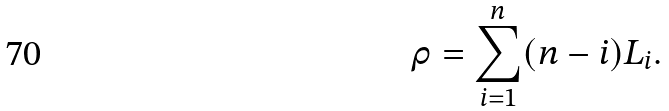Convert formula to latex. <formula><loc_0><loc_0><loc_500><loc_500>\rho = \sum _ { i = 1 } ^ { n } ( n - i ) L _ { i } .</formula> 